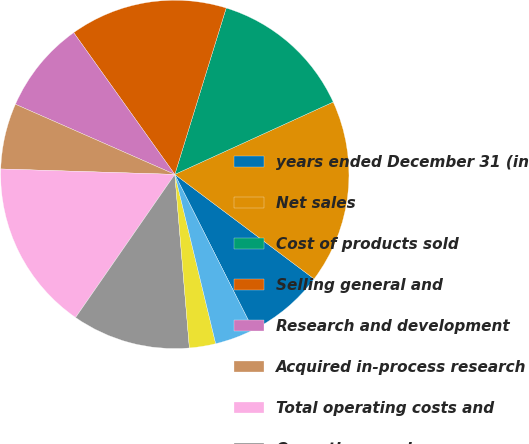Convert chart to OTSL. <chart><loc_0><loc_0><loc_500><loc_500><pie_chart><fcel>years ended December 31 (in<fcel>Net sales<fcel>Cost of products sold<fcel>Selling general and<fcel>Research and development<fcel>Acquired in-process research<fcel>Total operating costs and<fcel>Operating earnings<fcel>Interest expense net<fcel>Net foreign exchange (gain)<nl><fcel>7.32%<fcel>17.07%<fcel>13.41%<fcel>14.63%<fcel>8.54%<fcel>6.1%<fcel>15.85%<fcel>10.98%<fcel>2.44%<fcel>3.66%<nl></chart> 